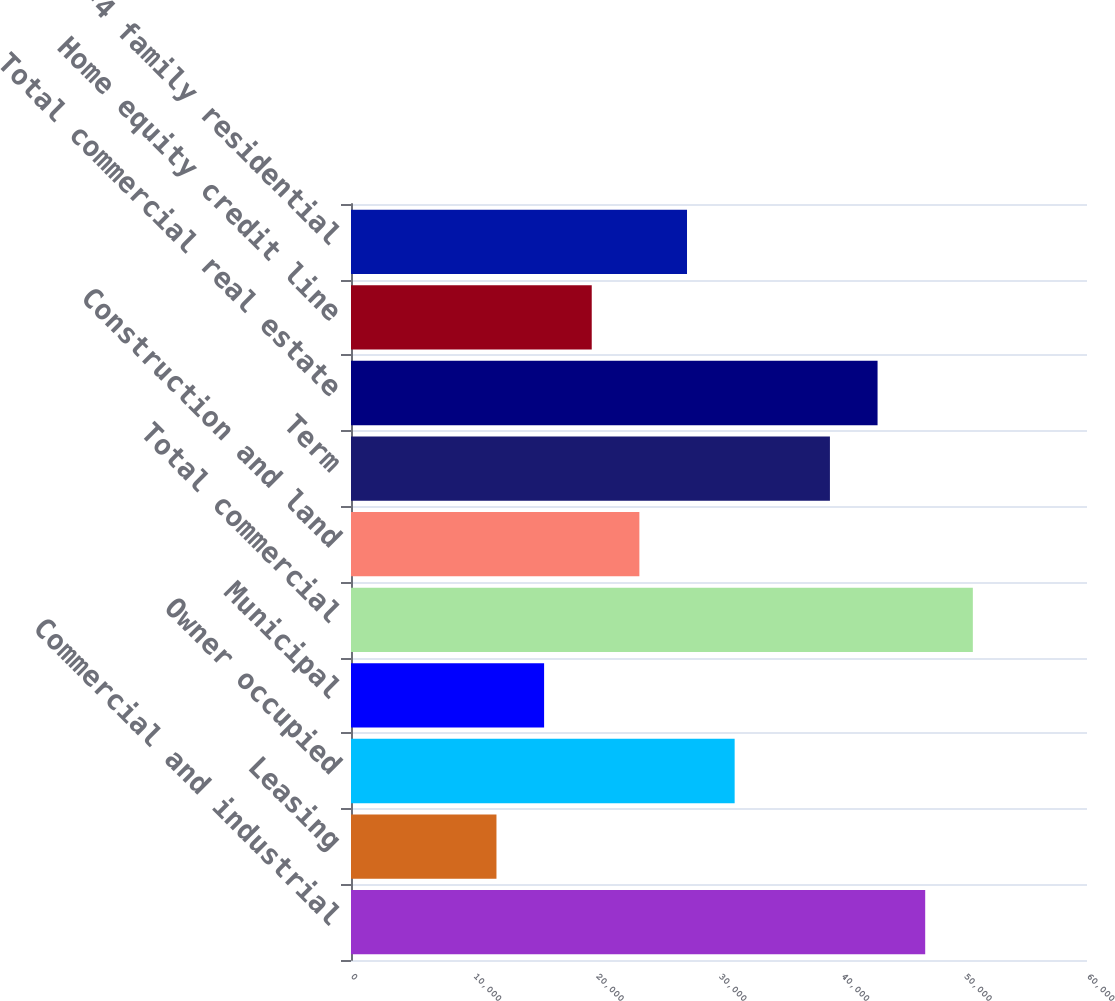Convert chart to OTSL. <chart><loc_0><loc_0><loc_500><loc_500><bar_chart><fcel>Commercial and industrial<fcel>Leasing<fcel>Owner occupied<fcel>Municipal<fcel>Total commercial<fcel>Construction and land<fcel>Term<fcel>Total commercial real estate<fcel>Home equity credit line<fcel>1-4 family residential<nl><fcel>46810<fcel>11858.5<fcel>31276<fcel>15742<fcel>50693.5<fcel>23509<fcel>39043<fcel>42926.5<fcel>19625.5<fcel>27392.5<nl></chart> 